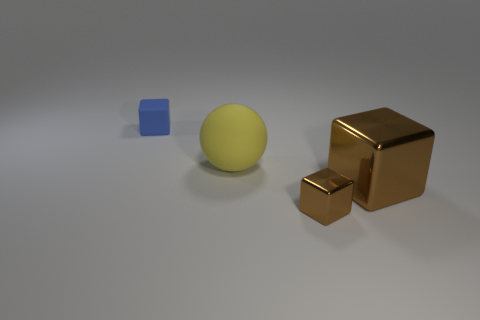Can you comment on the lighting direction in the scene? Certainly. The lighting in the image appears to be coming from the upper left side, as indicated by the shadows cast to the lower right of the objects. This can be inferred from the elongated shadows of the blue cube and the brown metallic blocks. Additionally, the highlights on the objects, particularly the reflective surfaces of the metallic blocks, suggest a single, strong light source, casting a soft glow on the surface and the objects themselves. 